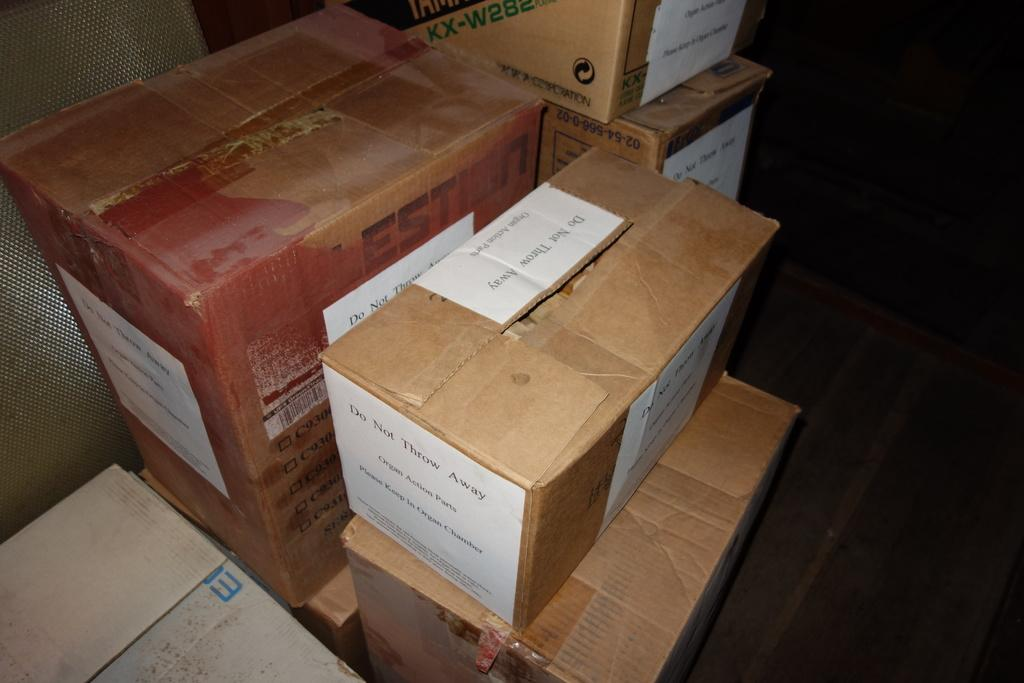<image>
Present a compact description of the photo's key features. A box with a note instructing not to throw it away on top is with other boxes. 